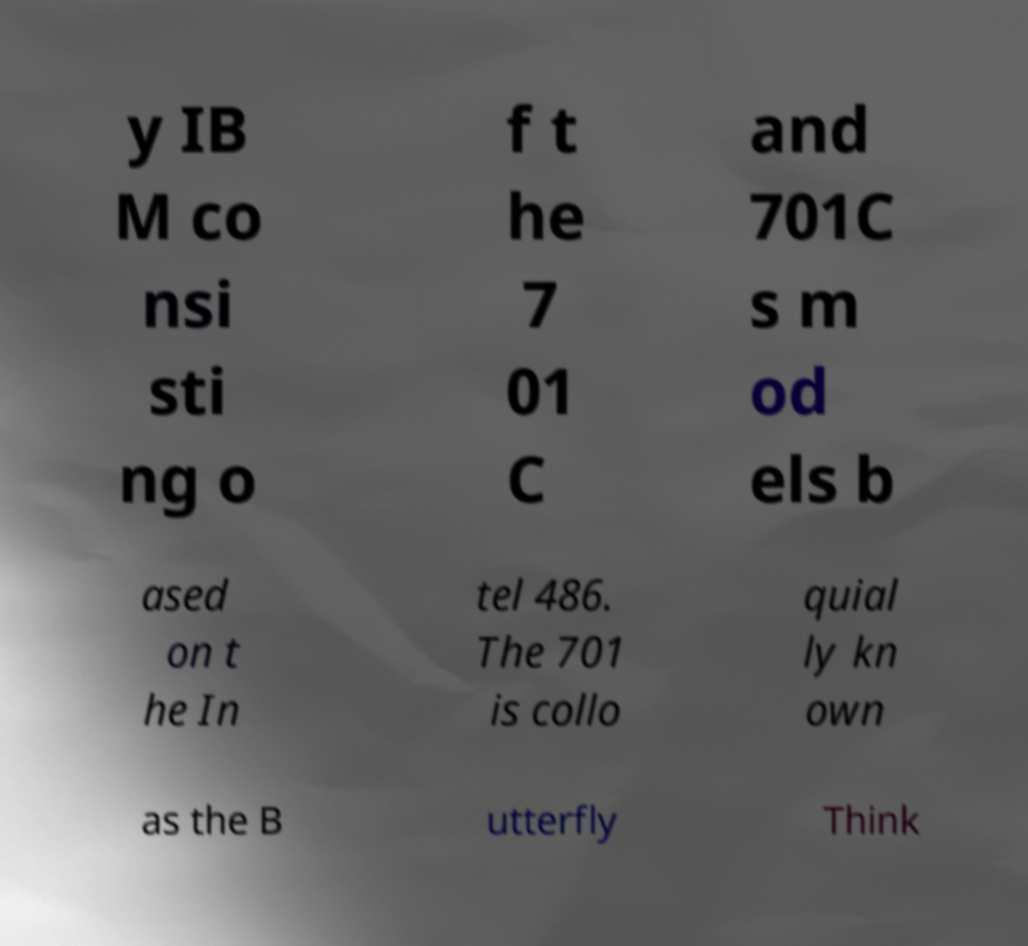What messages or text are displayed in this image? I need them in a readable, typed format. y IB M co nsi sti ng o f t he 7 01 C and 701C s m od els b ased on t he In tel 486. The 701 is collo quial ly kn own as the B utterfly Think 